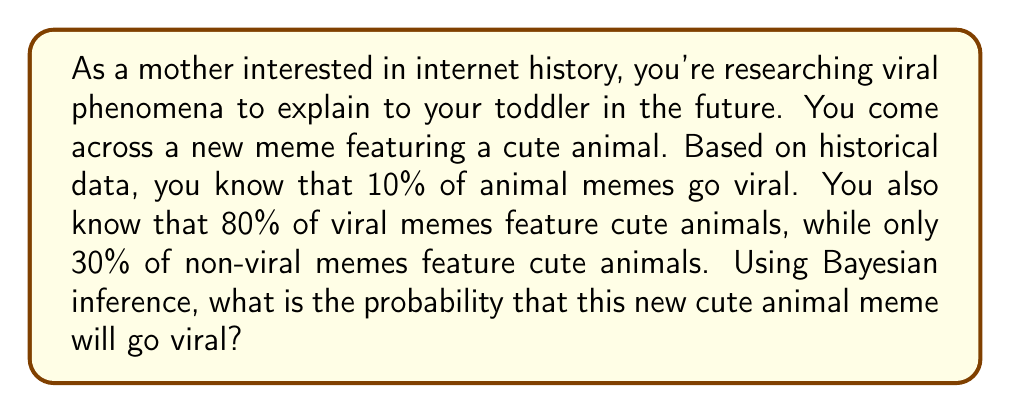Provide a solution to this math problem. Let's approach this problem using Bayes' theorem. We'll define the following events:

V: The meme goes viral
C: The meme features a cute animal

We're given the following probabilities:

$P(V) = 0.10$ (prior probability of a meme going viral)
$P(C|V) = 0.80$ (probability of a cute animal given that the meme is viral)
$P(C|\text{not }V) = 0.30$ (probability of a cute animal given that the meme is not viral)

We want to find $P(V|C)$, the probability that the meme goes viral given that it features a cute animal.

Bayes' theorem states:

$$P(V|C) = \frac{P(C|V) \cdot P(V)}{P(C)}$$

We need to calculate $P(C)$ using the law of total probability:

$$P(C) = P(C|V) \cdot P(V) + P(C|\text{not }V) \cdot P(\text{not }V)$$

First, let's calculate $P(\text{not }V)$:

$$P(\text{not }V) = 1 - P(V) = 1 - 0.10 = 0.90$$

Now we can calculate $P(C)$:

$$\begin{align*}
P(C) &= 0.80 \cdot 0.10 + 0.30 \cdot 0.90 \\
&= 0.08 + 0.27 \\
&= 0.35
\end{align*}$$

Now we have all the components to apply Bayes' theorem:

$$\begin{align*}
P(V|C) &= \frac{P(C|V) \cdot P(V)}{P(C)} \\
&= \frac{0.80 \cdot 0.10}{0.35} \\
&= \frac{0.08}{0.35} \\
&\approx 0.2286
\end{align*}$$

Therefore, the probability that this new cute animal meme will go viral is approximately 0.2286 or 22.86%.
Answer: $P(V|C) \approx 0.2286$ or 22.86% 